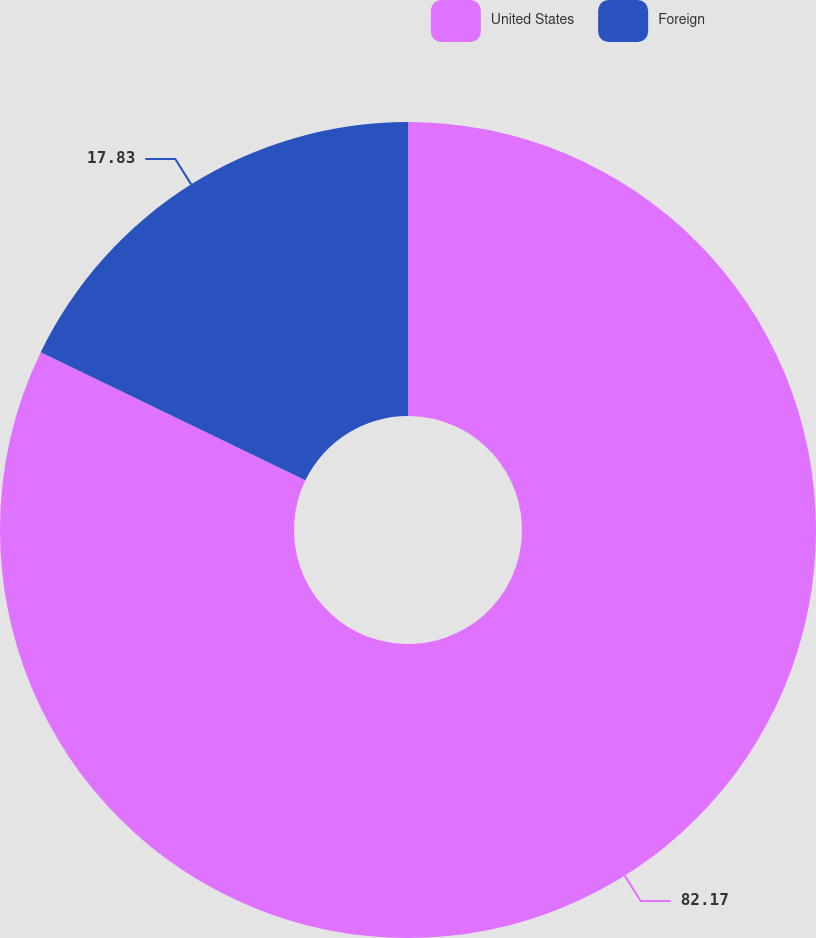Convert chart to OTSL. <chart><loc_0><loc_0><loc_500><loc_500><pie_chart><fcel>United States<fcel>Foreign<nl><fcel>82.17%<fcel>17.83%<nl></chart> 